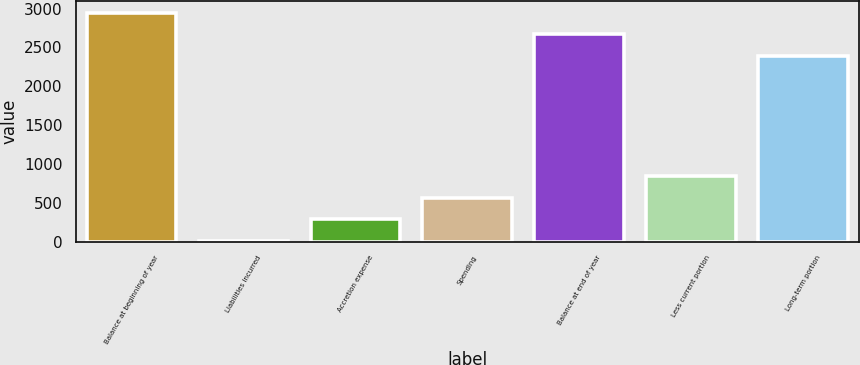<chart> <loc_0><loc_0><loc_500><loc_500><bar_chart><fcel>Balance at beginning of year<fcel>Liabilities incurred<fcel>Accretion expense<fcel>Spending<fcel>Balance at end of year<fcel>Less current portion<fcel>Long-term portion<nl><fcel>2946.8<fcel>12<fcel>287.9<fcel>563.8<fcel>2670.9<fcel>839.7<fcel>2395<nl></chart> 